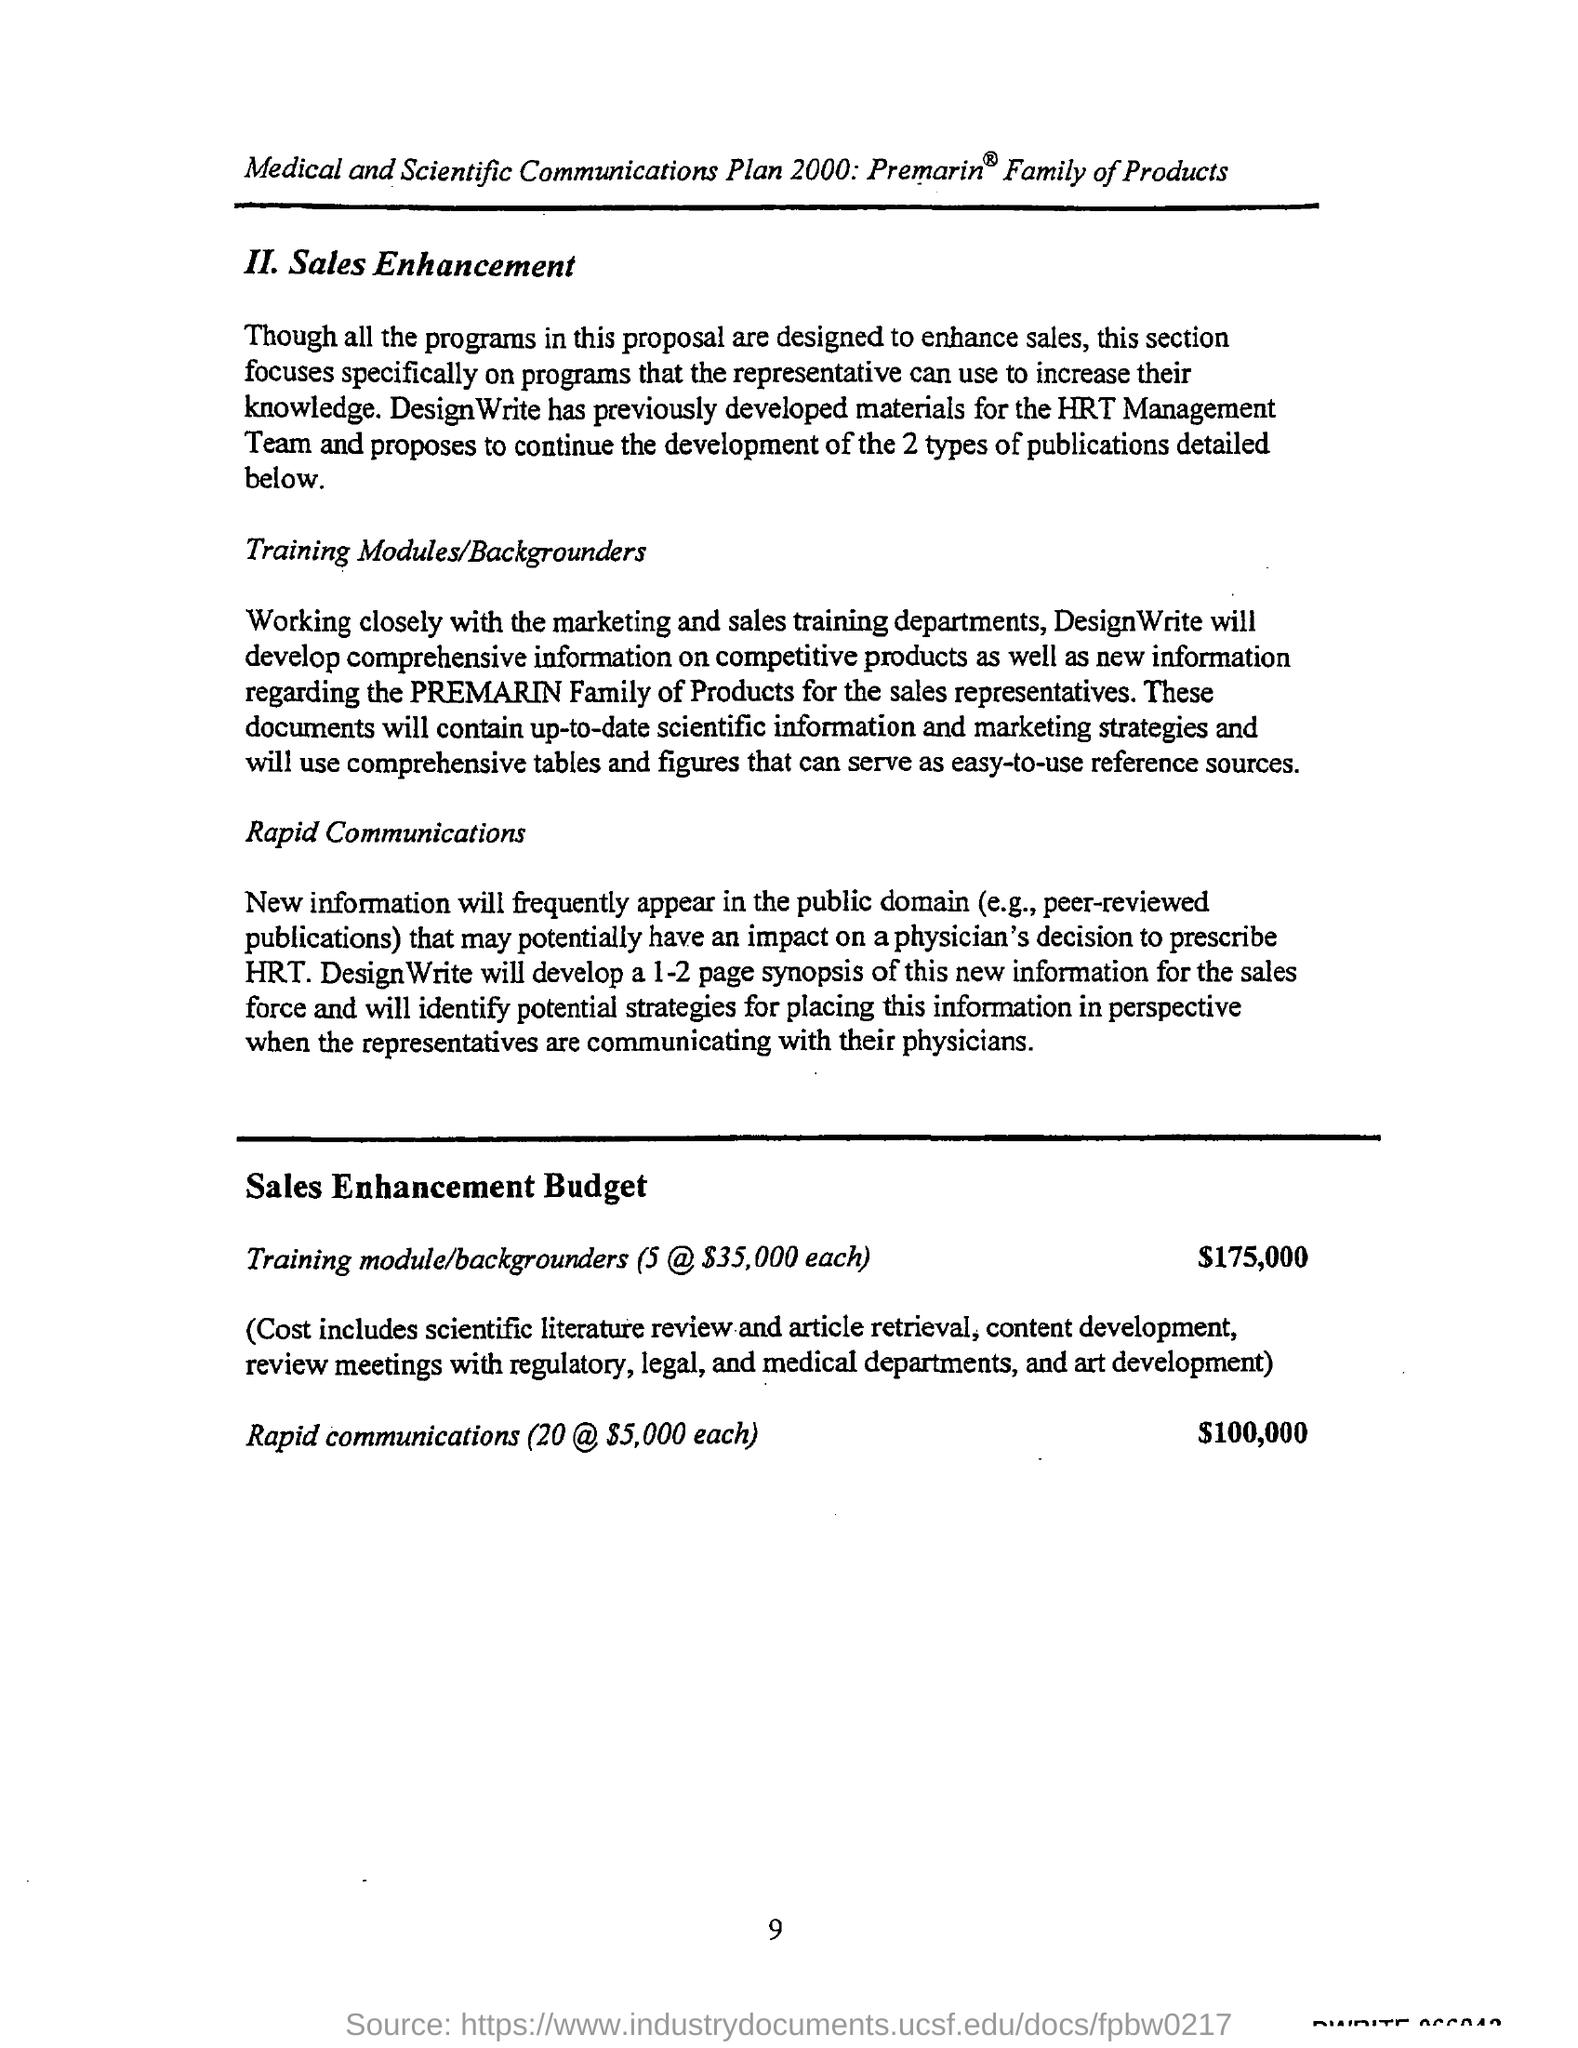What is the budget amount for training module?
Offer a very short reply. 175,000. What is the main motive of this programme design?
Ensure brevity in your answer.  To enhance sales. 